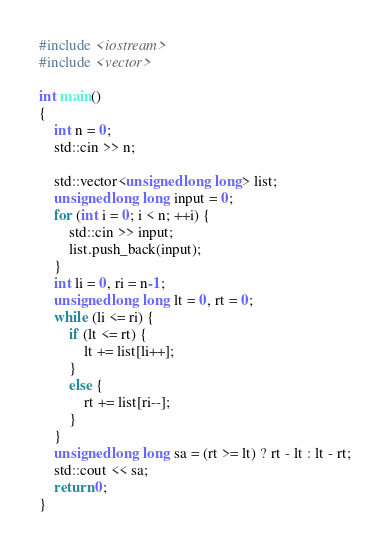Convert code to text. <code><loc_0><loc_0><loc_500><loc_500><_C++_>#include <iostream>
#include <vector>

int main()
{
	int n = 0;
	std::cin >> n;

	std::vector<unsigned long long> list;
	unsigned long long input = 0;
	for (int i = 0; i < n; ++i) {
		std::cin >> input;
		list.push_back(input);
	}
	int li = 0, ri = n-1;
	unsigned long long lt = 0, rt = 0;
	while (li <= ri) {
		if (lt <= rt) {
			lt += list[li++];
		}
		else {
			rt += list[ri--];
		}
	}
	unsigned long long sa = (rt >= lt) ? rt - lt : lt - rt;
	std::cout << sa;
	return 0;
}
</code> 